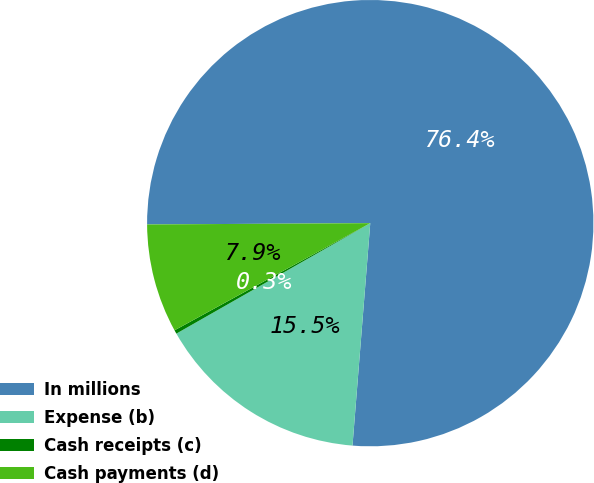<chart> <loc_0><loc_0><loc_500><loc_500><pie_chart><fcel>In millions<fcel>Expense (b)<fcel>Cash receipts (c)<fcel>Cash payments (d)<nl><fcel>76.37%<fcel>15.49%<fcel>0.27%<fcel>7.88%<nl></chart> 